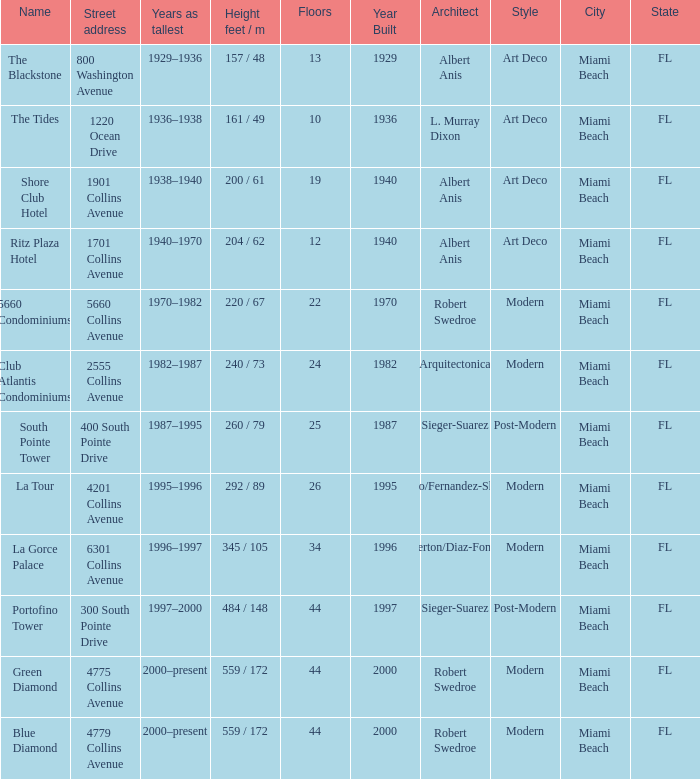What is the height of the Tides with less than 34 floors? 161 / 49. 